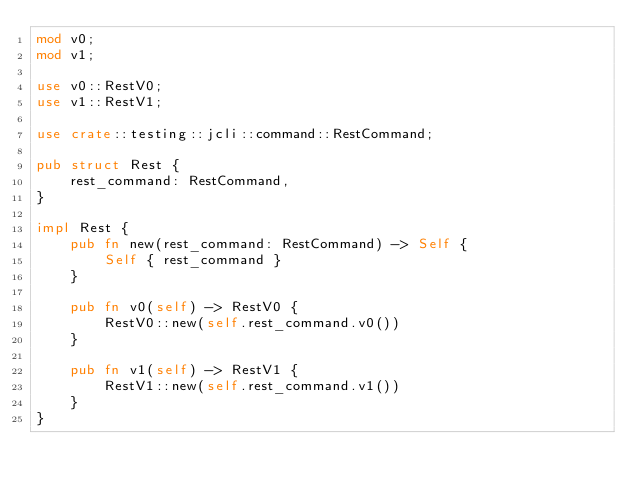<code> <loc_0><loc_0><loc_500><loc_500><_Rust_>mod v0;
mod v1;

use v0::RestV0;
use v1::RestV1;

use crate::testing::jcli::command::RestCommand;

pub struct Rest {
    rest_command: RestCommand,
}

impl Rest {
    pub fn new(rest_command: RestCommand) -> Self {
        Self { rest_command }
    }

    pub fn v0(self) -> RestV0 {
        RestV0::new(self.rest_command.v0())
    }

    pub fn v1(self) -> RestV1 {
        RestV1::new(self.rest_command.v1())
    }
}
</code> 